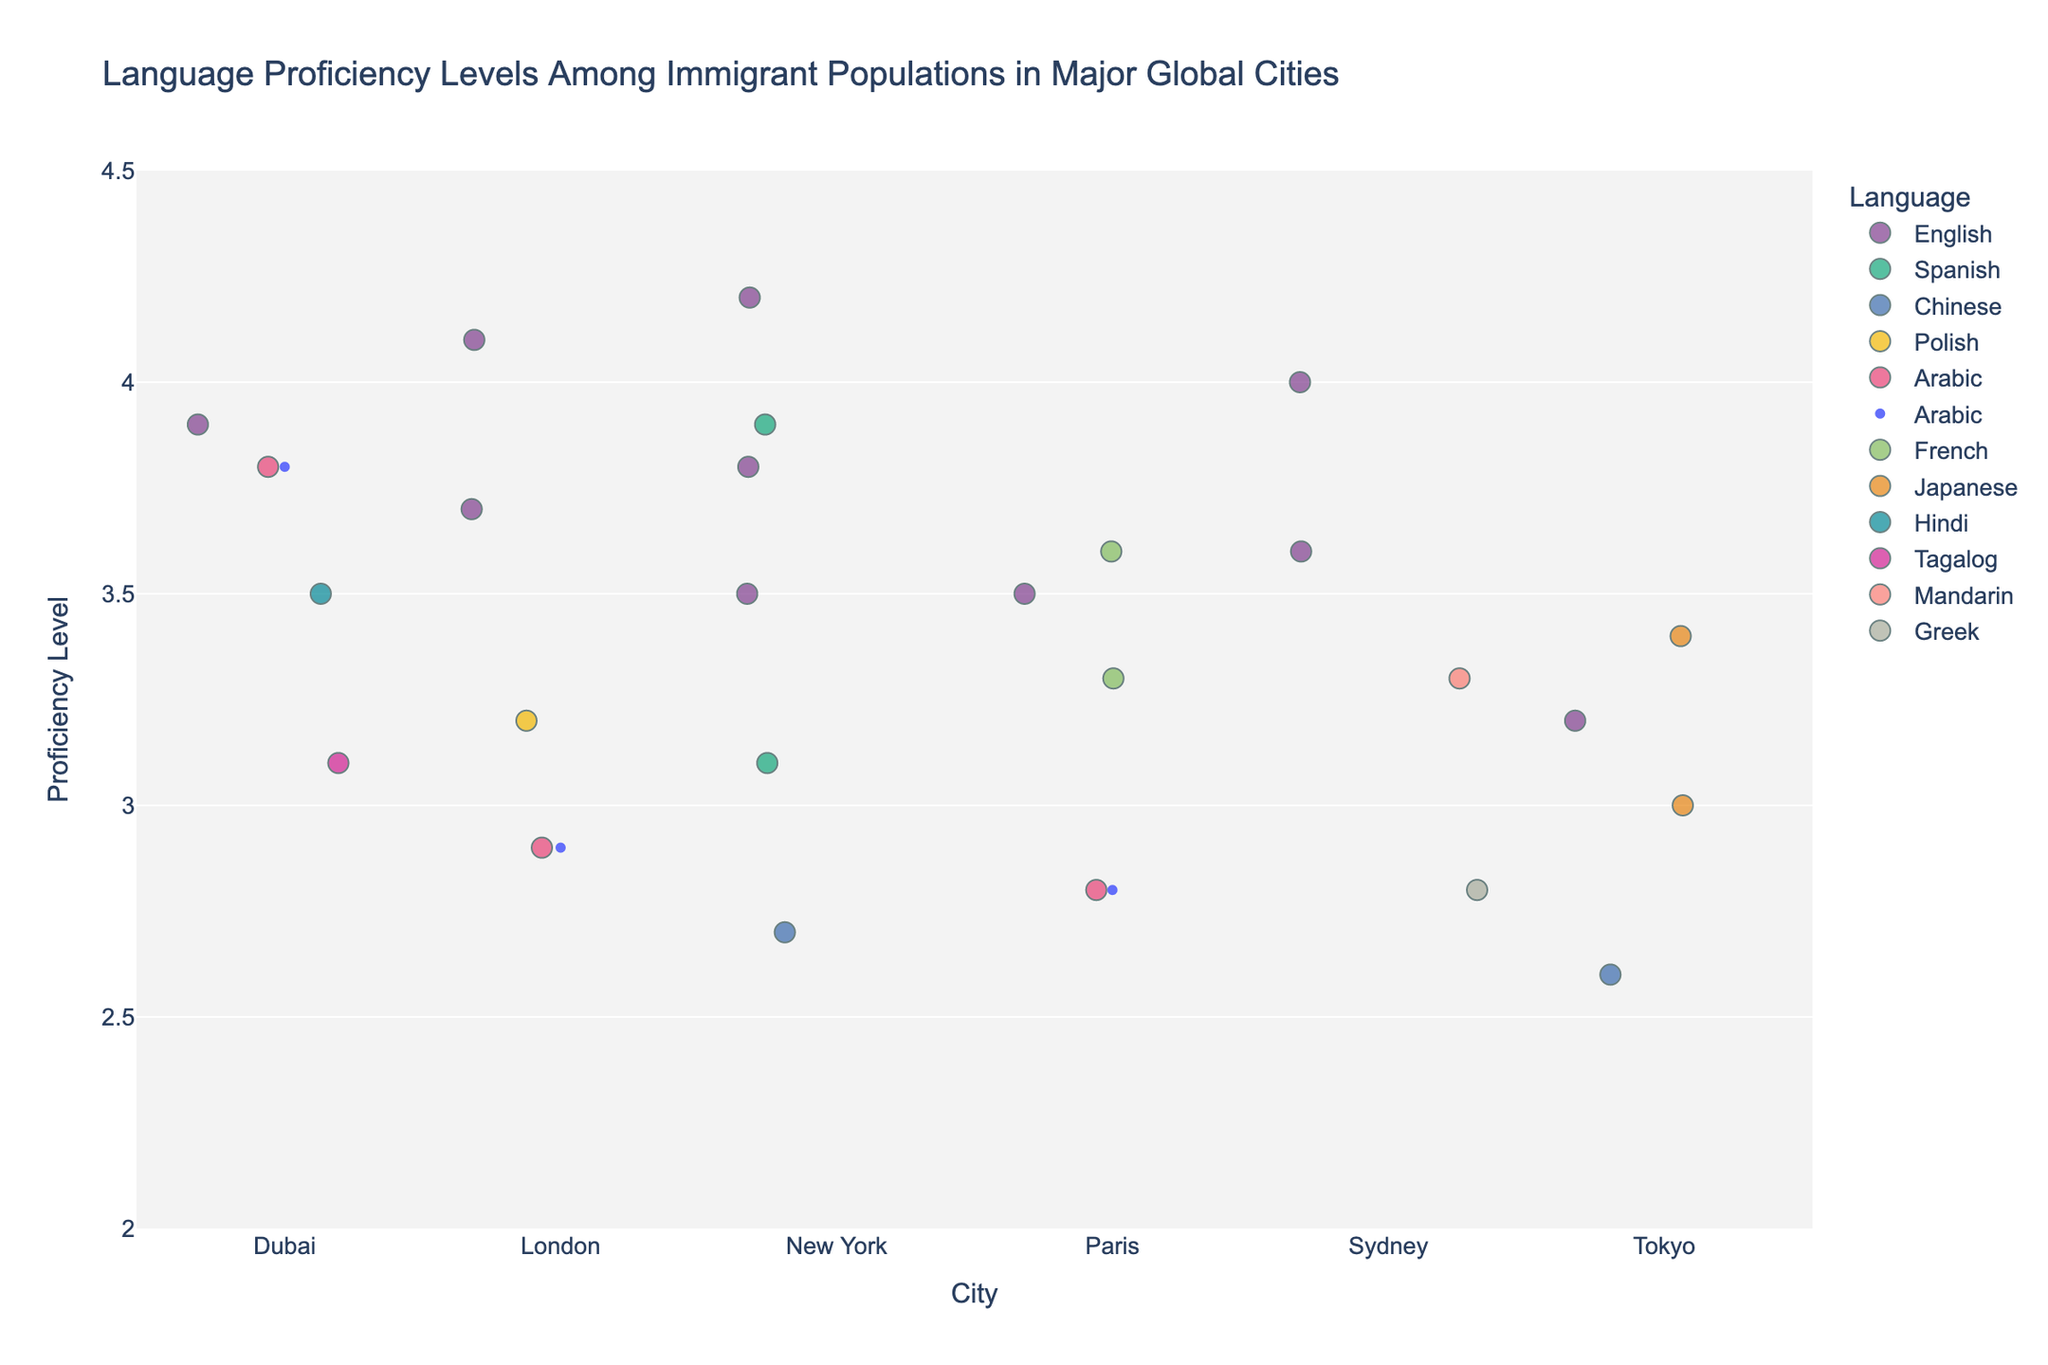What is the range of proficiency levels shown in the strip plot? The range of proficiency levels in the strip plot can be observed on the y-axis, showing values from 2 to 4.5.
Answer: 2 to 4.5 Which language has the highest average proficiency in New York? To find the highest average proficiency for languages in New York, observe the mean points for each language. English appears to have the highest mean value within New York.
Answer: English How many languages are represented in the city of Paris? Look at the colors and legend to identify the different languages plotted for Paris. There are French, Arabic, and English.
Answer: 3 What is the proficiency level of the lowest proficiency language in Tokyo? Find the points corresponding to the lowest values on the y-axis within the Tokyo plot. The lowest point is for Chinese with a value of 2.6.
Answer: 2.6 Compare the average proficiency levels for Arabic and Hindi in Dubai. Which is higher? Observe the mean points added to the plot for Dubai. The mean proficiency for Arabic and Hindi can be compared, and Arabic has a higher average proficiency.
Answer: Arabic What is the average proficiency level of English across all cities shown? Calculate the average by summing all the proficiency levels of English from each city and then divide by the number of data points. (4.2 + 3.8 + 3.5 + 4.1 + 3.7 + 3.5 + 3.2 + 3.9 + 4.0 + 3.6) / 10 = (37.5 / 10).
Answer: 3.75 What is the median proficiency level of Japanese in Tokyo? For Japanese in Tokyo, list the proficiency levels (3.4 and 3.0), and find the median, which is the middle value or the average of the middle values. Median of (3.4, 3.0) = (3.4 + 3.0) / 2.
Answer: 3.2 Which city has the broadest range of proficiency levels across all languages? Assess the range of data points (spread on the y-axis) for each city. New York has the broadest range from 2.7 to 4.2.
Answer: New York Is there any city where English is not spoken? By checking the language colors in each city, Paris, Tokyo, and Dubai all have plots for English. Every city contains at least one proficiency data point for English.
Answer: No 